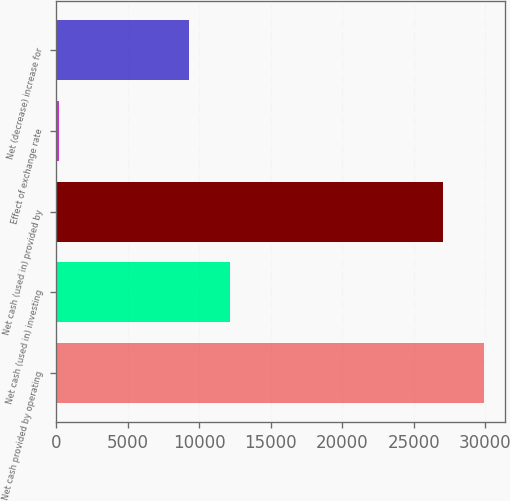Convert chart. <chart><loc_0><loc_0><loc_500><loc_500><bar_chart><fcel>Net cash provided by operating<fcel>Net cash (used in) investing<fcel>Net cash (used in) provided by<fcel>Effect of exchange rate<fcel>Net (decrease) increase for<nl><fcel>29905.5<fcel>12179.5<fcel>27015<fcel>215<fcel>9289<nl></chart> 